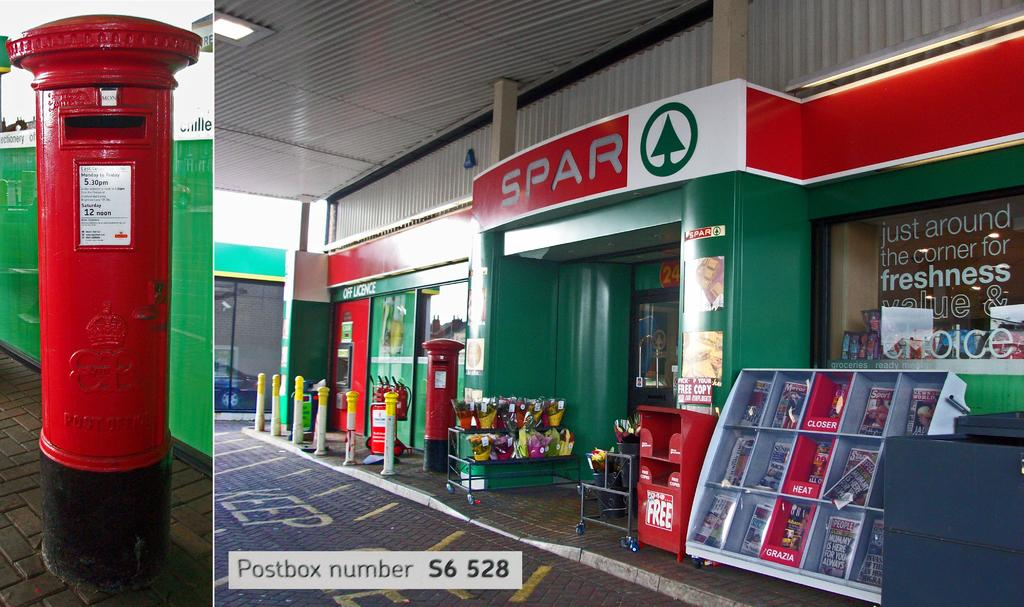<image>
Provide a brief description of the given image. Lots of items are for sale outside of the Spar store. 